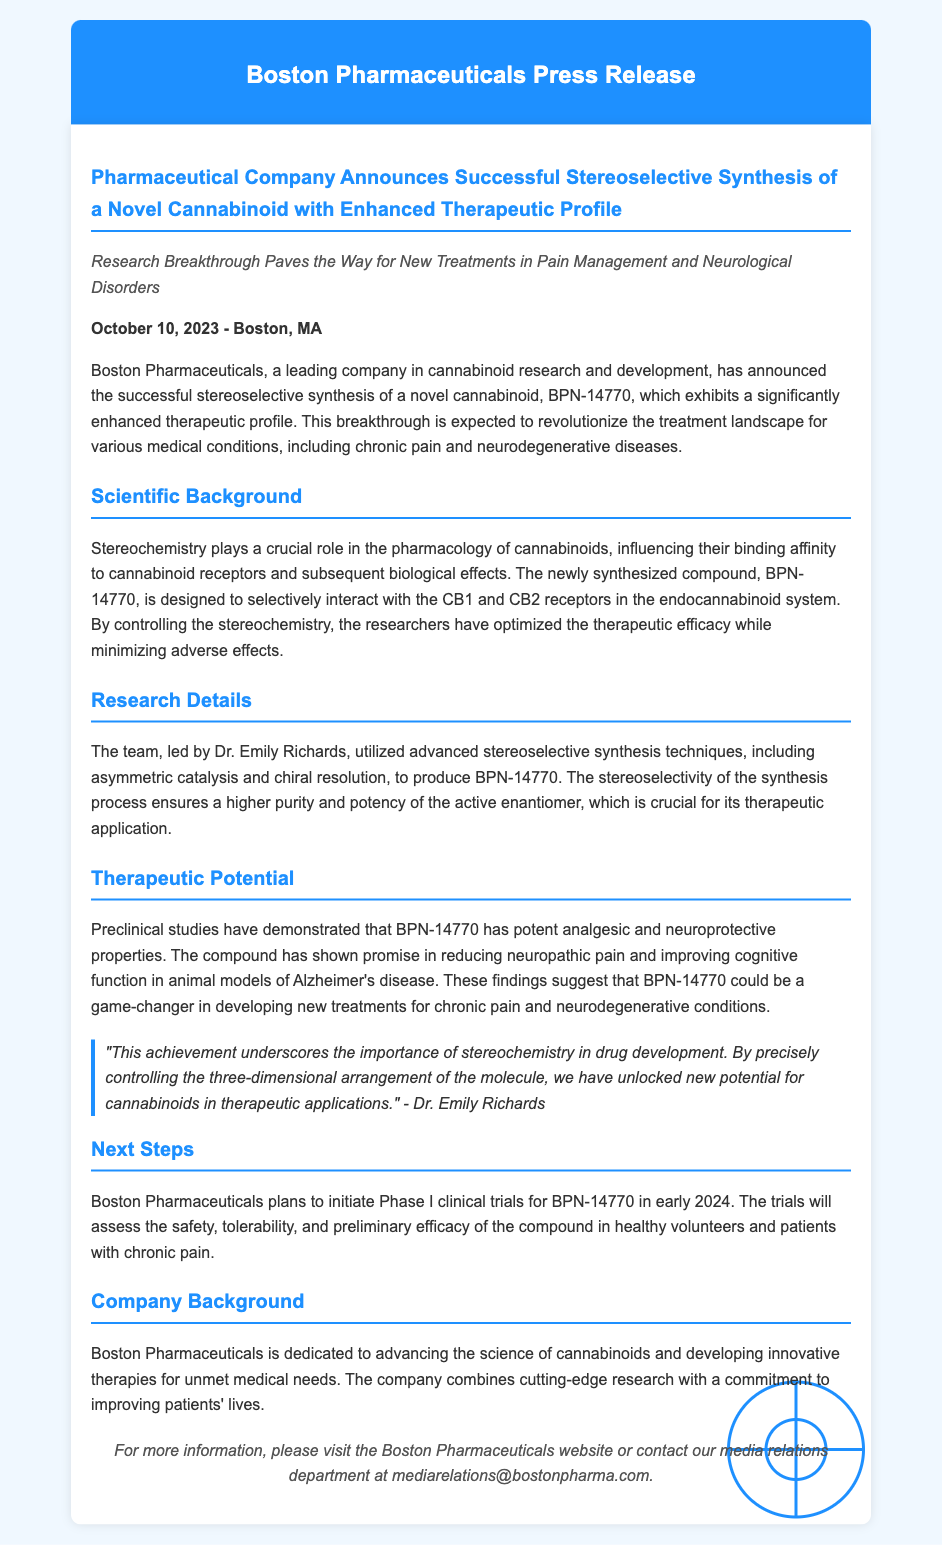What is the name of the novel cannabinoid? The document states that the novel cannabinoid is called BPN-14770.
Answer: BPN-14770 Who is the lead researcher mentioned in the press release? The lead researcher is Dr. Emily Richards as mentioned in the research details section.
Answer: Dr. Emily Richards When does Boston Pharmaceuticals plan to initiate Phase I clinical trials? The document specifies that Phase I clinical trials for BPN-14770 will begin in early 2024.
Answer: Early 2024 What therapeutic properties does BPN-14770 exhibit? Preclinical studies have shown that BPN-14770 has potent analgesic and neuroprotective properties.
Answer: Analgesic and neuroprotective What techniques were utilized to synthesize BPN-14770? The synthesis techniques mentioned include asymmetric catalysis and chiral resolution.
Answer: Asymmetric catalysis and chiral resolution What medical conditions may benefit from BPN-14770? The document identifies chronic pain and neurodegenerative diseases as conditions that may benefit from BPN-14770.
Answer: Chronic pain and neurodegenerative diseases How does stereochemistry affect the pharmacology of cannabinoids? The document notes that stereochemistry influences binding affinity to cannabinoid receptors and biological effects.
Answer: Binding affinity to cannabinoid receptors What is Boston Pharmaceuticals’ commitment as stated in the document? The company is dedicated to advancing the science of cannabinoids and improving patients' lives.
Answer: Improving patients' lives 